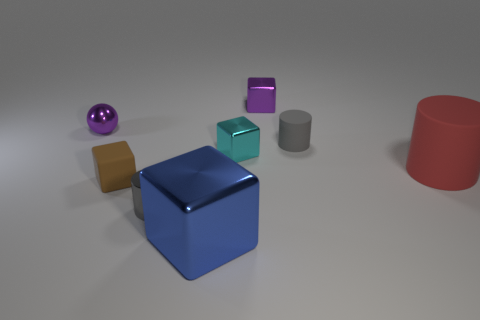Add 1 purple metal balls. How many objects exist? 9 Subtract all matte cylinders. How many cylinders are left? 1 Subtract all red cylinders. How many cylinders are left? 2 Subtract all red spheres. Subtract all green cylinders. How many spheres are left? 1 Subtract all gray cubes. How many cyan spheres are left? 0 Subtract all small blue metal cubes. Subtract all small brown matte cubes. How many objects are left? 7 Add 2 big objects. How many big objects are left? 4 Add 4 shiny blocks. How many shiny blocks exist? 7 Subtract 0 green spheres. How many objects are left? 8 Subtract all spheres. How many objects are left? 7 